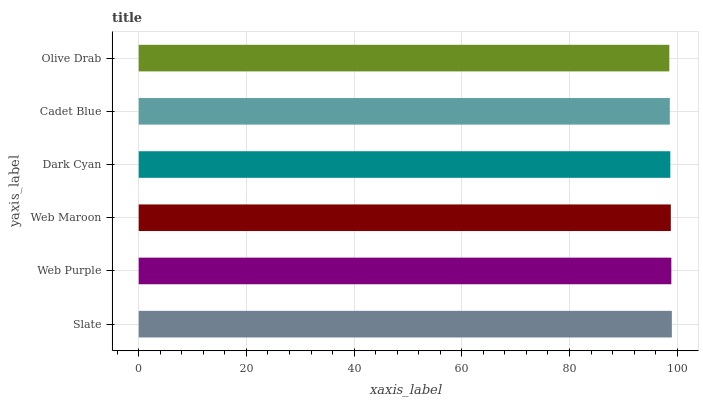Is Olive Drab the minimum?
Answer yes or no. Yes. Is Slate the maximum?
Answer yes or no. Yes. Is Web Purple the minimum?
Answer yes or no. No. Is Web Purple the maximum?
Answer yes or no. No. Is Slate greater than Web Purple?
Answer yes or no. Yes. Is Web Purple less than Slate?
Answer yes or no. Yes. Is Web Purple greater than Slate?
Answer yes or no. No. Is Slate less than Web Purple?
Answer yes or no. No. Is Web Maroon the high median?
Answer yes or no. Yes. Is Dark Cyan the low median?
Answer yes or no. Yes. Is Olive Drab the high median?
Answer yes or no. No. Is Slate the low median?
Answer yes or no. No. 